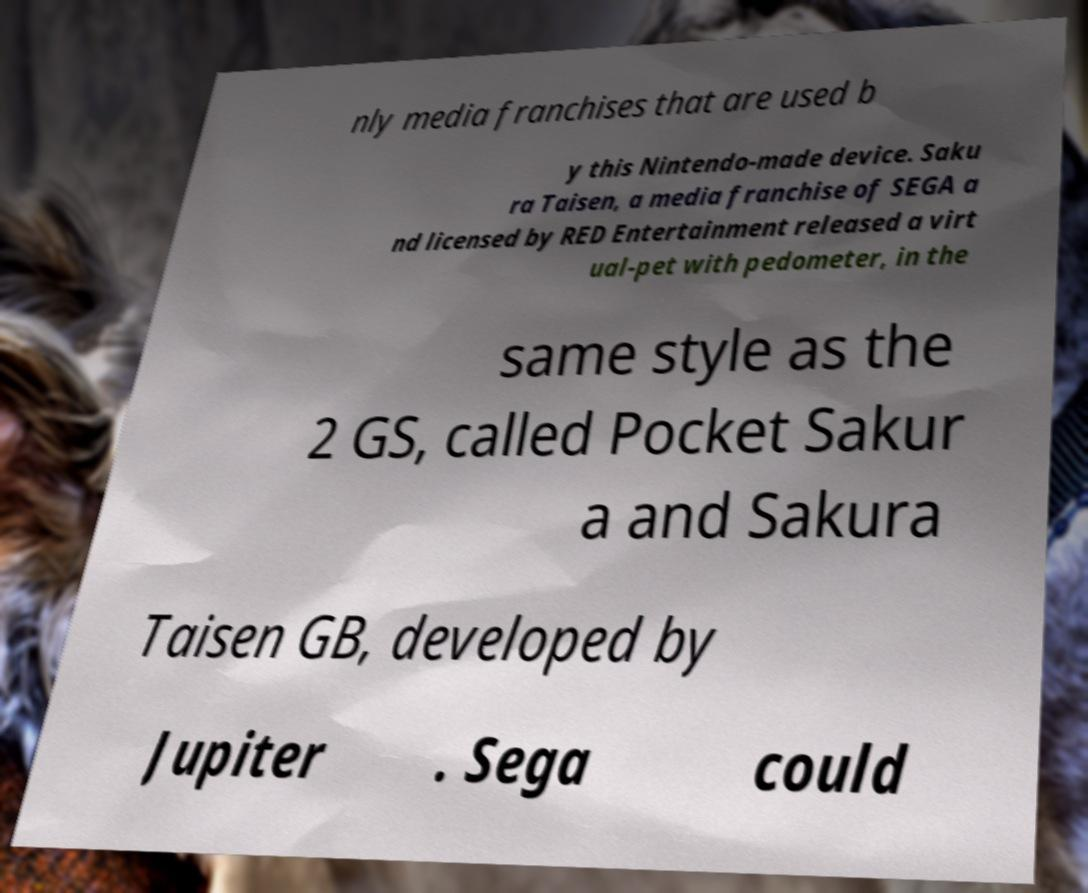Can you read and provide the text displayed in the image?This photo seems to have some interesting text. Can you extract and type it out for me? nly media franchises that are used b y this Nintendo-made device. Saku ra Taisen, a media franchise of SEGA a nd licensed by RED Entertainment released a virt ual-pet with pedometer, in the same style as the 2 GS, called Pocket Sakur a and Sakura Taisen GB, developed by Jupiter . Sega could 